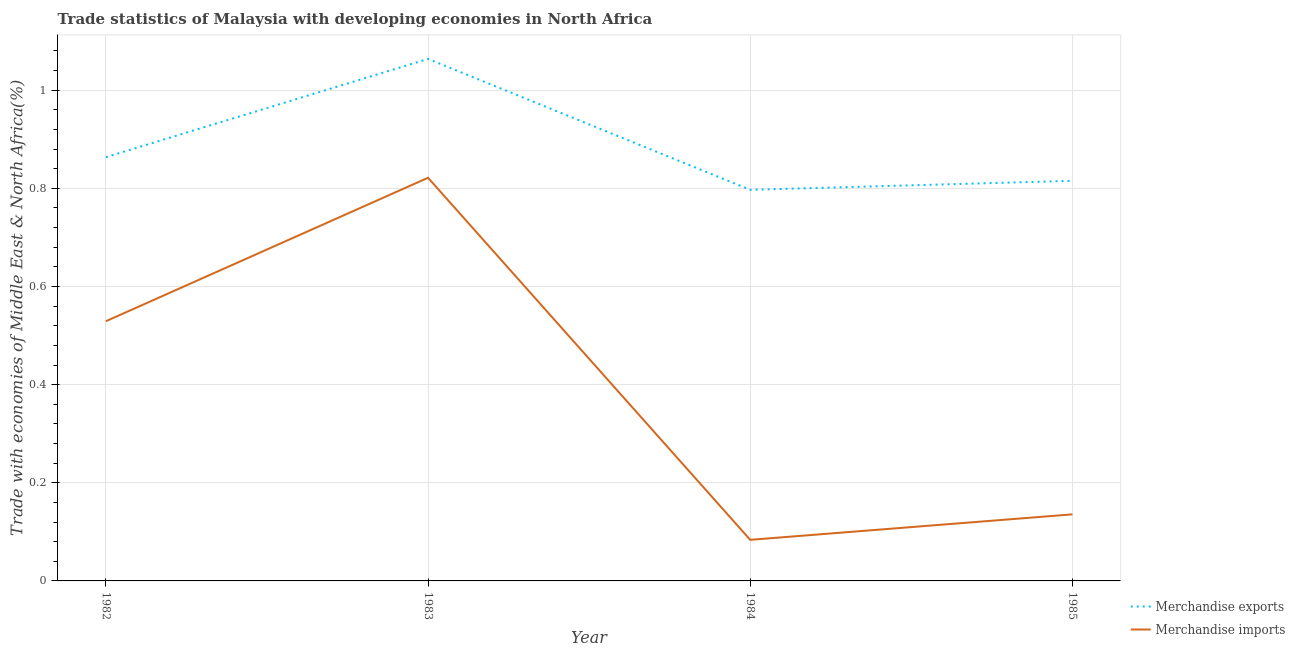How many different coloured lines are there?
Offer a very short reply. 2. Is the number of lines equal to the number of legend labels?
Provide a succinct answer. Yes. What is the merchandise imports in 1983?
Ensure brevity in your answer.  0.82. Across all years, what is the maximum merchandise imports?
Your answer should be very brief. 0.82. Across all years, what is the minimum merchandise exports?
Provide a short and direct response. 0.8. In which year was the merchandise imports maximum?
Your answer should be compact. 1983. What is the total merchandise exports in the graph?
Offer a very short reply. 3.54. What is the difference between the merchandise exports in 1982 and that in 1984?
Offer a terse response. 0.07. What is the difference between the merchandise imports in 1982 and the merchandise exports in 1984?
Your answer should be compact. -0.27. What is the average merchandise exports per year?
Ensure brevity in your answer.  0.88. In the year 1985, what is the difference between the merchandise exports and merchandise imports?
Offer a very short reply. 0.68. What is the ratio of the merchandise imports in 1982 to that in 1985?
Provide a succinct answer. 3.9. Is the difference between the merchandise exports in 1982 and 1984 greater than the difference between the merchandise imports in 1982 and 1984?
Ensure brevity in your answer.  No. What is the difference between the highest and the second highest merchandise imports?
Give a very brief answer. 0.29. What is the difference between the highest and the lowest merchandise imports?
Your response must be concise. 0.74. Is the sum of the merchandise imports in 1983 and 1985 greater than the maximum merchandise exports across all years?
Keep it short and to the point. No. Does the merchandise imports monotonically increase over the years?
Your answer should be compact. No. Is the merchandise exports strictly greater than the merchandise imports over the years?
Give a very brief answer. Yes. Is the merchandise exports strictly less than the merchandise imports over the years?
Give a very brief answer. No. How many lines are there?
Offer a terse response. 2. How many years are there in the graph?
Make the answer very short. 4. Where does the legend appear in the graph?
Ensure brevity in your answer.  Bottom right. How are the legend labels stacked?
Provide a succinct answer. Vertical. What is the title of the graph?
Ensure brevity in your answer.  Trade statistics of Malaysia with developing economies in North Africa. Does "RDB concessional" appear as one of the legend labels in the graph?
Make the answer very short. No. What is the label or title of the X-axis?
Give a very brief answer. Year. What is the label or title of the Y-axis?
Offer a very short reply. Trade with economies of Middle East & North Africa(%). What is the Trade with economies of Middle East & North Africa(%) in Merchandise exports in 1982?
Your answer should be compact. 0.86. What is the Trade with economies of Middle East & North Africa(%) of Merchandise imports in 1982?
Ensure brevity in your answer.  0.53. What is the Trade with economies of Middle East & North Africa(%) in Merchandise exports in 1983?
Give a very brief answer. 1.06. What is the Trade with economies of Middle East & North Africa(%) in Merchandise imports in 1983?
Make the answer very short. 0.82. What is the Trade with economies of Middle East & North Africa(%) of Merchandise exports in 1984?
Your response must be concise. 0.8. What is the Trade with economies of Middle East & North Africa(%) in Merchandise imports in 1984?
Your response must be concise. 0.08. What is the Trade with economies of Middle East & North Africa(%) in Merchandise exports in 1985?
Your answer should be compact. 0.82. What is the Trade with economies of Middle East & North Africa(%) of Merchandise imports in 1985?
Keep it short and to the point. 0.14. Across all years, what is the maximum Trade with economies of Middle East & North Africa(%) in Merchandise exports?
Offer a terse response. 1.06. Across all years, what is the maximum Trade with economies of Middle East & North Africa(%) in Merchandise imports?
Your answer should be compact. 0.82. Across all years, what is the minimum Trade with economies of Middle East & North Africa(%) of Merchandise exports?
Keep it short and to the point. 0.8. Across all years, what is the minimum Trade with economies of Middle East & North Africa(%) in Merchandise imports?
Provide a succinct answer. 0.08. What is the total Trade with economies of Middle East & North Africa(%) of Merchandise exports in the graph?
Your response must be concise. 3.54. What is the total Trade with economies of Middle East & North Africa(%) of Merchandise imports in the graph?
Provide a short and direct response. 1.57. What is the difference between the Trade with economies of Middle East & North Africa(%) in Merchandise exports in 1982 and that in 1983?
Offer a terse response. -0.2. What is the difference between the Trade with economies of Middle East & North Africa(%) of Merchandise imports in 1982 and that in 1983?
Keep it short and to the point. -0.29. What is the difference between the Trade with economies of Middle East & North Africa(%) of Merchandise exports in 1982 and that in 1984?
Make the answer very short. 0.07. What is the difference between the Trade with economies of Middle East & North Africa(%) in Merchandise imports in 1982 and that in 1984?
Give a very brief answer. 0.45. What is the difference between the Trade with economies of Middle East & North Africa(%) in Merchandise exports in 1982 and that in 1985?
Provide a short and direct response. 0.05. What is the difference between the Trade with economies of Middle East & North Africa(%) of Merchandise imports in 1982 and that in 1985?
Provide a short and direct response. 0.39. What is the difference between the Trade with economies of Middle East & North Africa(%) of Merchandise exports in 1983 and that in 1984?
Keep it short and to the point. 0.27. What is the difference between the Trade with economies of Middle East & North Africa(%) of Merchandise imports in 1983 and that in 1984?
Your answer should be very brief. 0.74. What is the difference between the Trade with economies of Middle East & North Africa(%) of Merchandise exports in 1983 and that in 1985?
Keep it short and to the point. 0.25. What is the difference between the Trade with economies of Middle East & North Africa(%) of Merchandise imports in 1983 and that in 1985?
Keep it short and to the point. 0.69. What is the difference between the Trade with economies of Middle East & North Africa(%) of Merchandise exports in 1984 and that in 1985?
Offer a very short reply. -0.02. What is the difference between the Trade with economies of Middle East & North Africa(%) of Merchandise imports in 1984 and that in 1985?
Keep it short and to the point. -0.05. What is the difference between the Trade with economies of Middle East & North Africa(%) of Merchandise exports in 1982 and the Trade with economies of Middle East & North Africa(%) of Merchandise imports in 1983?
Your answer should be very brief. 0.04. What is the difference between the Trade with economies of Middle East & North Africa(%) of Merchandise exports in 1982 and the Trade with economies of Middle East & North Africa(%) of Merchandise imports in 1984?
Offer a terse response. 0.78. What is the difference between the Trade with economies of Middle East & North Africa(%) in Merchandise exports in 1982 and the Trade with economies of Middle East & North Africa(%) in Merchandise imports in 1985?
Make the answer very short. 0.73. What is the difference between the Trade with economies of Middle East & North Africa(%) of Merchandise exports in 1983 and the Trade with economies of Middle East & North Africa(%) of Merchandise imports in 1984?
Provide a short and direct response. 0.98. What is the difference between the Trade with economies of Middle East & North Africa(%) of Merchandise exports in 1983 and the Trade with economies of Middle East & North Africa(%) of Merchandise imports in 1985?
Offer a very short reply. 0.93. What is the difference between the Trade with economies of Middle East & North Africa(%) of Merchandise exports in 1984 and the Trade with economies of Middle East & North Africa(%) of Merchandise imports in 1985?
Make the answer very short. 0.66. What is the average Trade with economies of Middle East & North Africa(%) of Merchandise exports per year?
Give a very brief answer. 0.88. What is the average Trade with economies of Middle East & North Africa(%) in Merchandise imports per year?
Your response must be concise. 0.39. In the year 1982, what is the difference between the Trade with economies of Middle East & North Africa(%) in Merchandise exports and Trade with economies of Middle East & North Africa(%) in Merchandise imports?
Provide a succinct answer. 0.33. In the year 1983, what is the difference between the Trade with economies of Middle East & North Africa(%) of Merchandise exports and Trade with economies of Middle East & North Africa(%) of Merchandise imports?
Your answer should be compact. 0.24. In the year 1984, what is the difference between the Trade with economies of Middle East & North Africa(%) in Merchandise exports and Trade with economies of Middle East & North Africa(%) in Merchandise imports?
Provide a succinct answer. 0.71. In the year 1985, what is the difference between the Trade with economies of Middle East & North Africa(%) of Merchandise exports and Trade with economies of Middle East & North Africa(%) of Merchandise imports?
Provide a succinct answer. 0.68. What is the ratio of the Trade with economies of Middle East & North Africa(%) of Merchandise exports in 1982 to that in 1983?
Your response must be concise. 0.81. What is the ratio of the Trade with economies of Middle East & North Africa(%) in Merchandise imports in 1982 to that in 1983?
Give a very brief answer. 0.64. What is the ratio of the Trade with economies of Middle East & North Africa(%) in Merchandise exports in 1982 to that in 1984?
Offer a terse response. 1.08. What is the ratio of the Trade with economies of Middle East & North Africa(%) in Merchandise imports in 1982 to that in 1984?
Your answer should be compact. 6.32. What is the ratio of the Trade with economies of Middle East & North Africa(%) in Merchandise exports in 1982 to that in 1985?
Keep it short and to the point. 1.06. What is the ratio of the Trade with economies of Middle East & North Africa(%) of Merchandise imports in 1982 to that in 1985?
Keep it short and to the point. 3.9. What is the ratio of the Trade with economies of Middle East & North Africa(%) in Merchandise exports in 1983 to that in 1984?
Offer a very short reply. 1.33. What is the ratio of the Trade with economies of Middle East & North Africa(%) of Merchandise imports in 1983 to that in 1984?
Your answer should be very brief. 9.81. What is the ratio of the Trade with economies of Middle East & North Africa(%) of Merchandise exports in 1983 to that in 1985?
Give a very brief answer. 1.3. What is the ratio of the Trade with economies of Middle East & North Africa(%) of Merchandise imports in 1983 to that in 1985?
Provide a short and direct response. 6.06. What is the ratio of the Trade with economies of Middle East & North Africa(%) in Merchandise exports in 1984 to that in 1985?
Offer a terse response. 0.98. What is the ratio of the Trade with economies of Middle East & North Africa(%) of Merchandise imports in 1984 to that in 1985?
Keep it short and to the point. 0.62. What is the difference between the highest and the second highest Trade with economies of Middle East & North Africa(%) of Merchandise exports?
Ensure brevity in your answer.  0.2. What is the difference between the highest and the second highest Trade with economies of Middle East & North Africa(%) in Merchandise imports?
Make the answer very short. 0.29. What is the difference between the highest and the lowest Trade with economies of Middle East & North Africa(%) in Merchandise exports?
Your response must be concise. 0.27. What is the difference between the highest and the lowest Trade with economies of Middle East & North Africa(%) of Merchandise imports?
Keep it short and to the point. 0.74. 